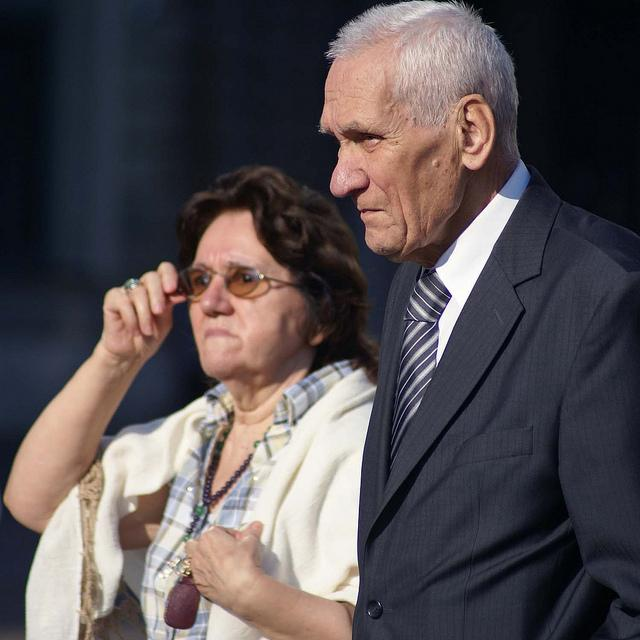Why are her glasses that color?

Choices:
A) paint
B) sunlight
C) prescription
D) style sunlight 